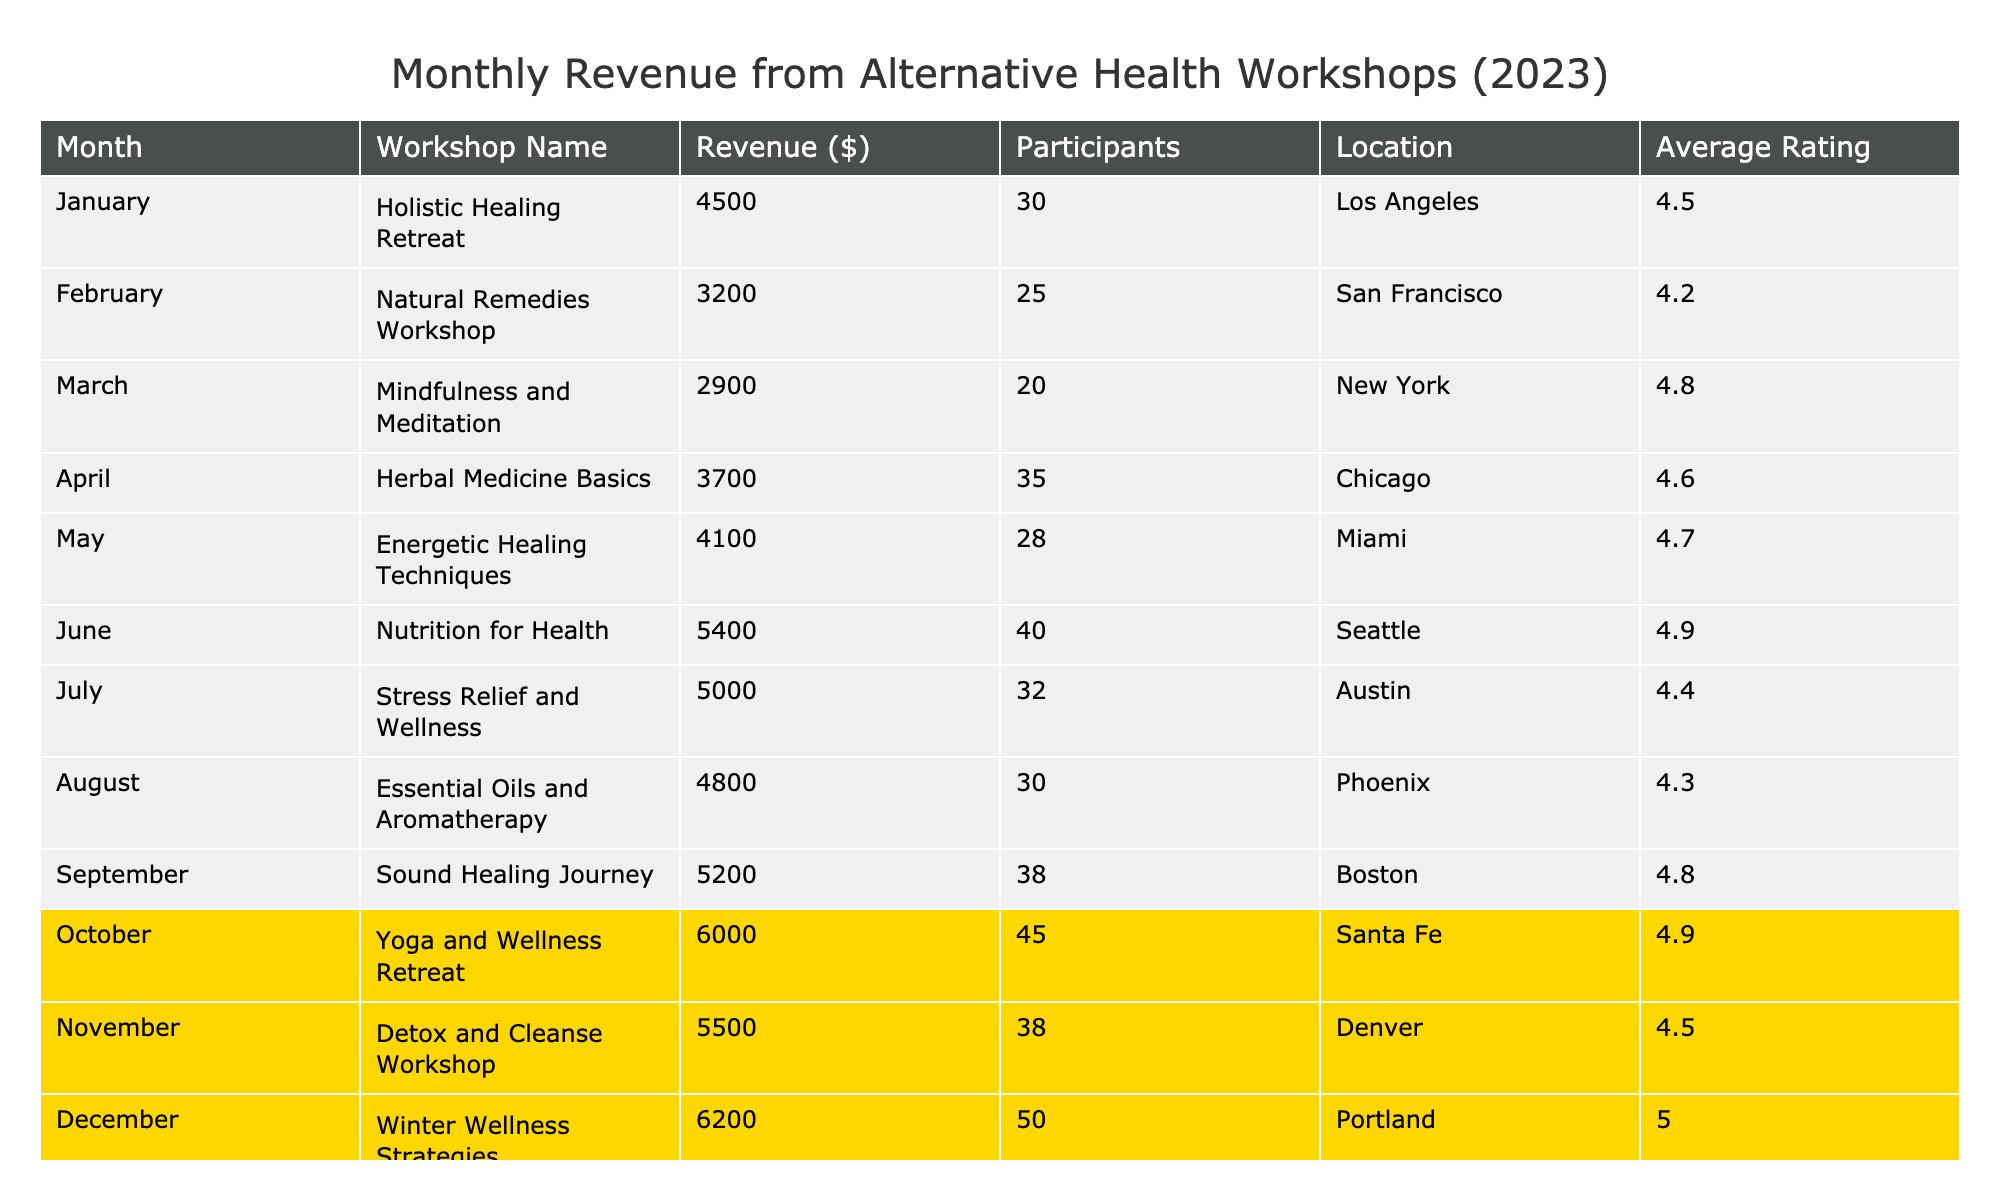What is the highest revenue from the workshops? The table lists the revenues for each workshop, and the highest value is 6200 dollars for the workshop "Winter Wellness Strategies."
Answer: 6200 Which month had the lowest participation in workshops? By checking the 'Participants' column, the workshop with the lowest attendance is in March, with only 20 participants in "Mindfulness and Meditation."
Answer: March How much more revenue did the "Detox and Cleanse Workshop" generate compared to the "Natural Remedies Workshop"? The revenue for "Detox and Cleanse Workshop" is 5500 dollars, and for "Natural Remedies Workshop," it is 3200 dollars. The difference is 5500 - 3200 = 2300 dollars.
Answer: 2300 What is the average rating for the workshops conducted in the months of June through August? The ratings for June, July, and August are 4.9, 4.4, and 4.3 respectively. To find the average, we add them up: 4.9 + 4.4 + 4.3 = 13.6 and divide by 3, resulting in 13.6 / 3 = 4.53.
Answer: 4.53 Which workshop had the highest number of participants, and how many were there? By looking at the 'Participants' column, we see that "Winter Wellness Strategies" had the most participants at 50.
Answer: Winter Wellness Strategies, 50 Is it true that the "Essential Oils and Aromatherapy" workshop had more revenue than the "Mindfulness and Meditation" workshop? "Essential Oils and Aromatherapy" had a revenue of 4800 dollars and "Mindfulness and Meditation" had 2900 dollars. Since 4800 is greater than 2900, the statement is true.
Answer: True How much total revenue was generated by the workshops held in the first half of the year (January to June)? The revenues from January to June are 4500, 3200, 2900, 3700, 4100, and 5400 dollars. Summing these gives 4500 + 3200 + 2900 + 3700 + 4100 + 5400 = 23800 dollars.
Answer: 23800 What percentage of participants gave a rating of 4.5 or higher? There are 8 workshops in total. Workshops with ratings of 4.5 or higher are February, April, May, June, July, September, October, November, and December, totaling 9 workshops. Thus, the percentage is (9 / 12) * 100 = 75%.
Answer: 75% Which two months had participants equal to or above 40? By reviewing the 'Participants' column, June and December both have participant numbers above 40, with 40 and 50 respectively.
Answer: June and December How much revenue did the workshops collectively generate in the second half of 2023 (July to December)? The revenues from July to December are 5000, 4800, 5200, 6000, 5500, and 6200 dollars. Summing these gives 5000 + 4800 + 5200 + 6000 + 5500 + 6200 = 33700 dollars.
Answer: 33700 